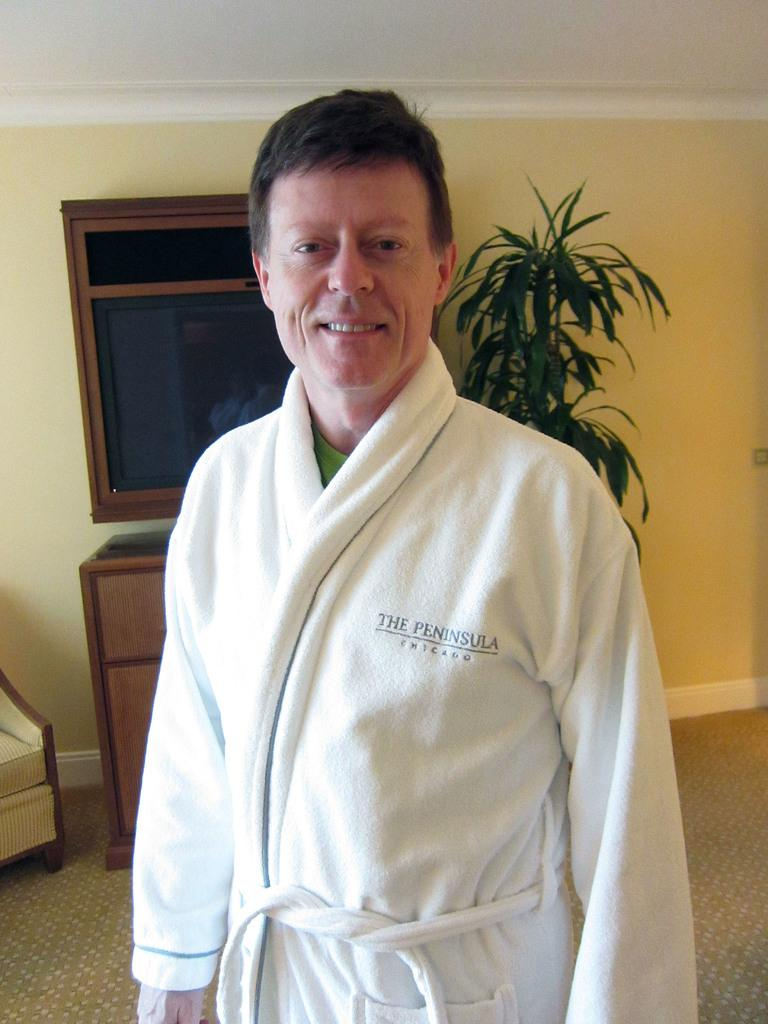<image>
Share a concise interpretation of the image provided. A man is wearing a white bath robe from The Peninsula in Chicago. 